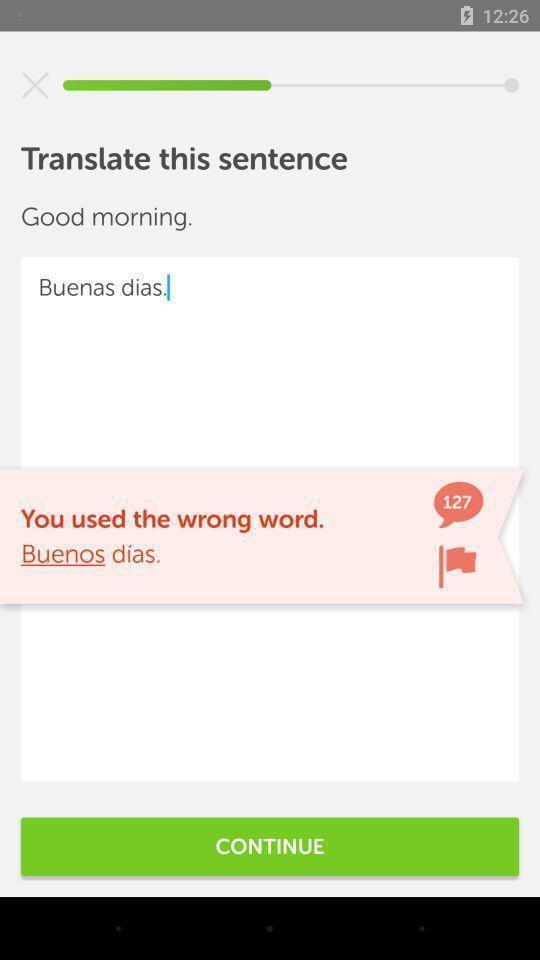Please provide a description for this image. Screen showing the page of a translation page. 